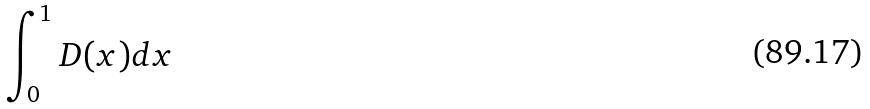Convert formula to latex. <formula><loc_0><loc_0><loc_500><loc_500>\int _ { 0 } ^ { 1 } D ( x ) d x</formula> 